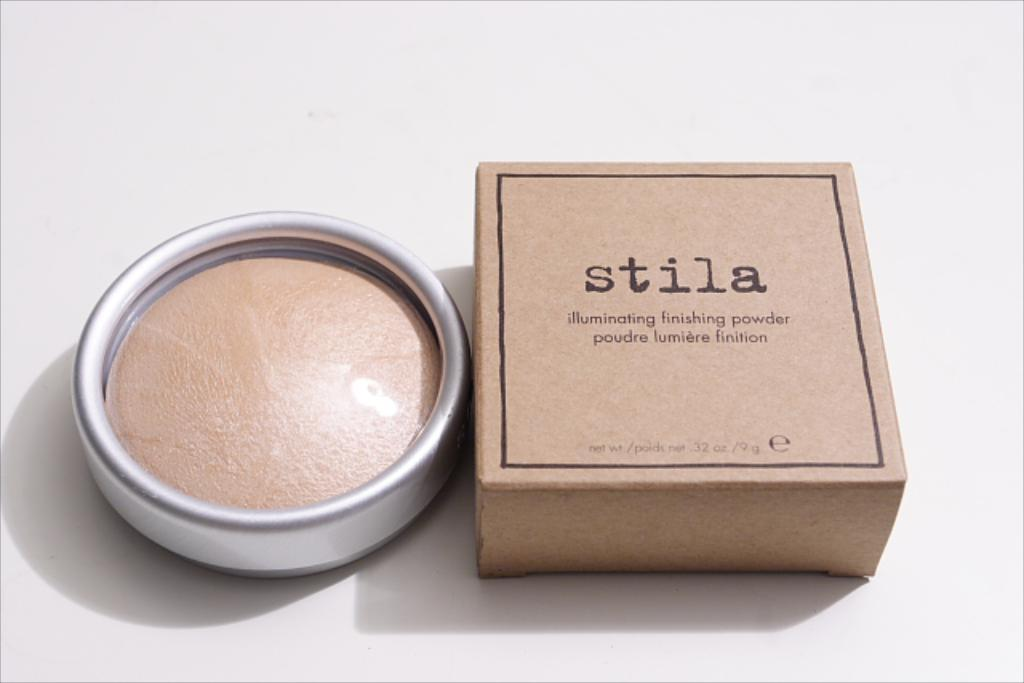<image>
Write a terse but informative summary of the picture. a brown box that has the word stila on it 